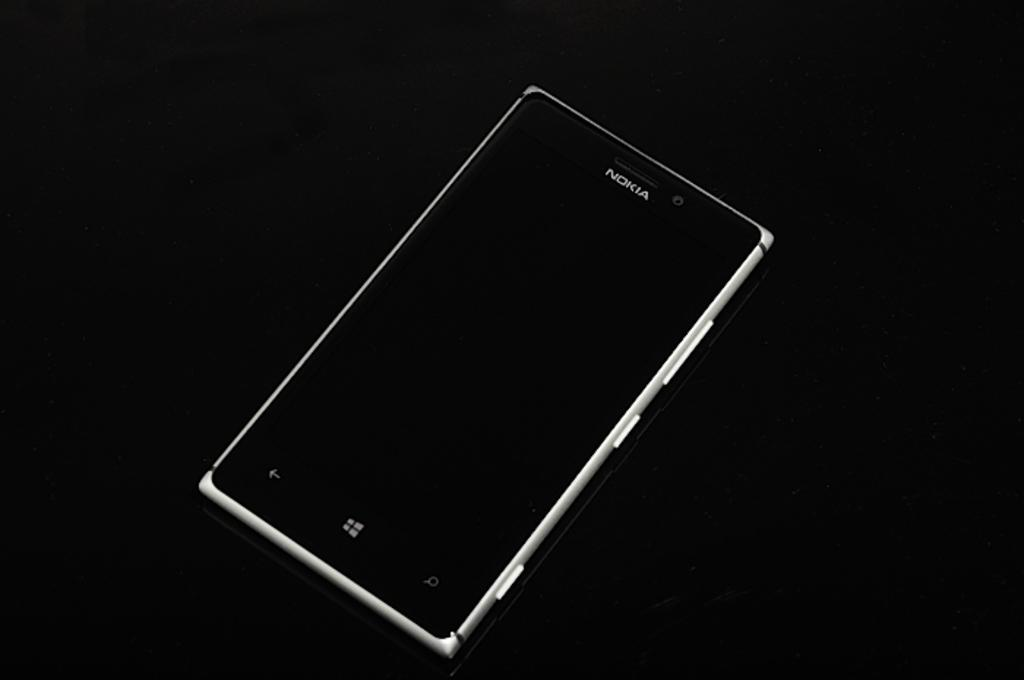<image>
Provide a brief description of the given image. A silver Nokia phone against a black back drop. 